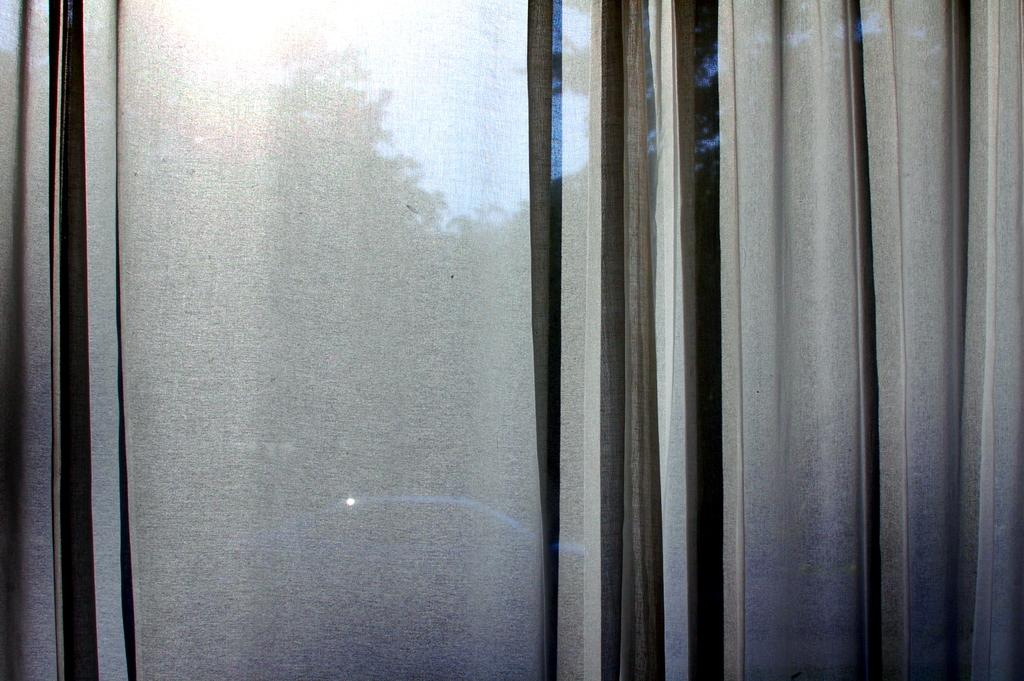What is hanging in the image? There is a curtain in the image. What type of vehicle is visible in the image? There is a car in the image. What can be seen behind the curtain? There are trees behind the curtain. What is visible at the top of the image? The sky is visible at the top of the image. How does the curtain guide the nerve in the image? There is no mention of a nerve in the image, and the curtain does not guide any nerves. 